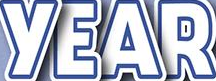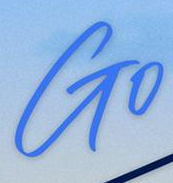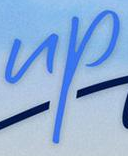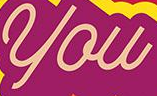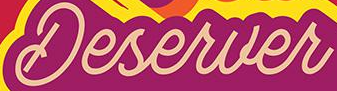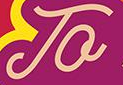Read the text content from these images in order, separated by a semicolon. YEAR; Go; up; you; Deserver; To 